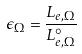Convert formula to latex. <formula><loc_0><loc_0><loc_500><loc_500>\epsilon _ { \Omega } = \frac { L _ { e , \Omega } } { L _ { e , \Omega } ^ { \circ } }</formula> 